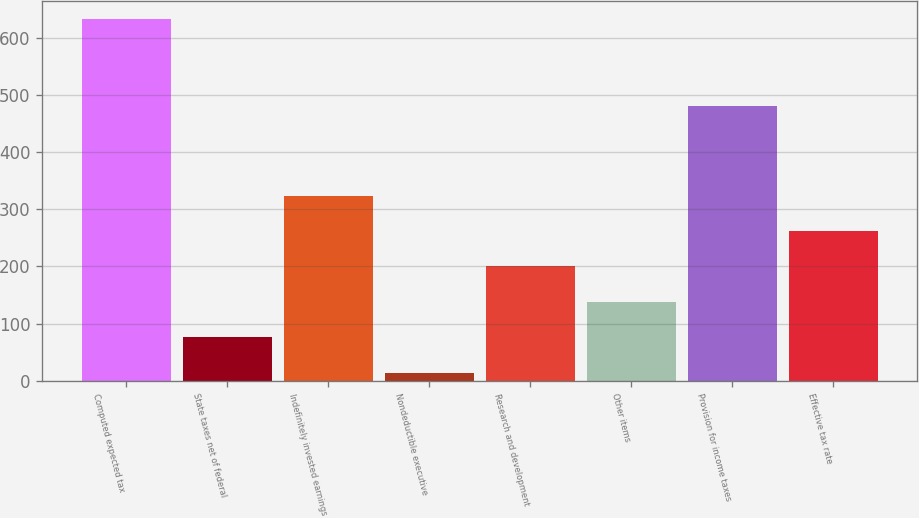<chart> <loc_0><loc_0><loc_500><loc_500><bar_chart><fcel>Computed expected tax<fcel>State taxes net of federal<fcel>Indefinitely invested earnings<fcel>Nondeductible executive<fcel>Research and development<fcel>Other items<fcel>Provision for income taxes<fcel>Effective tax rate<nl><fcel>633<fcel>75.9<fcel>323.5<fcel>14<fcel>199.7<fcel>137.8<fcel>480<fcel>261.6<nl></chart> 